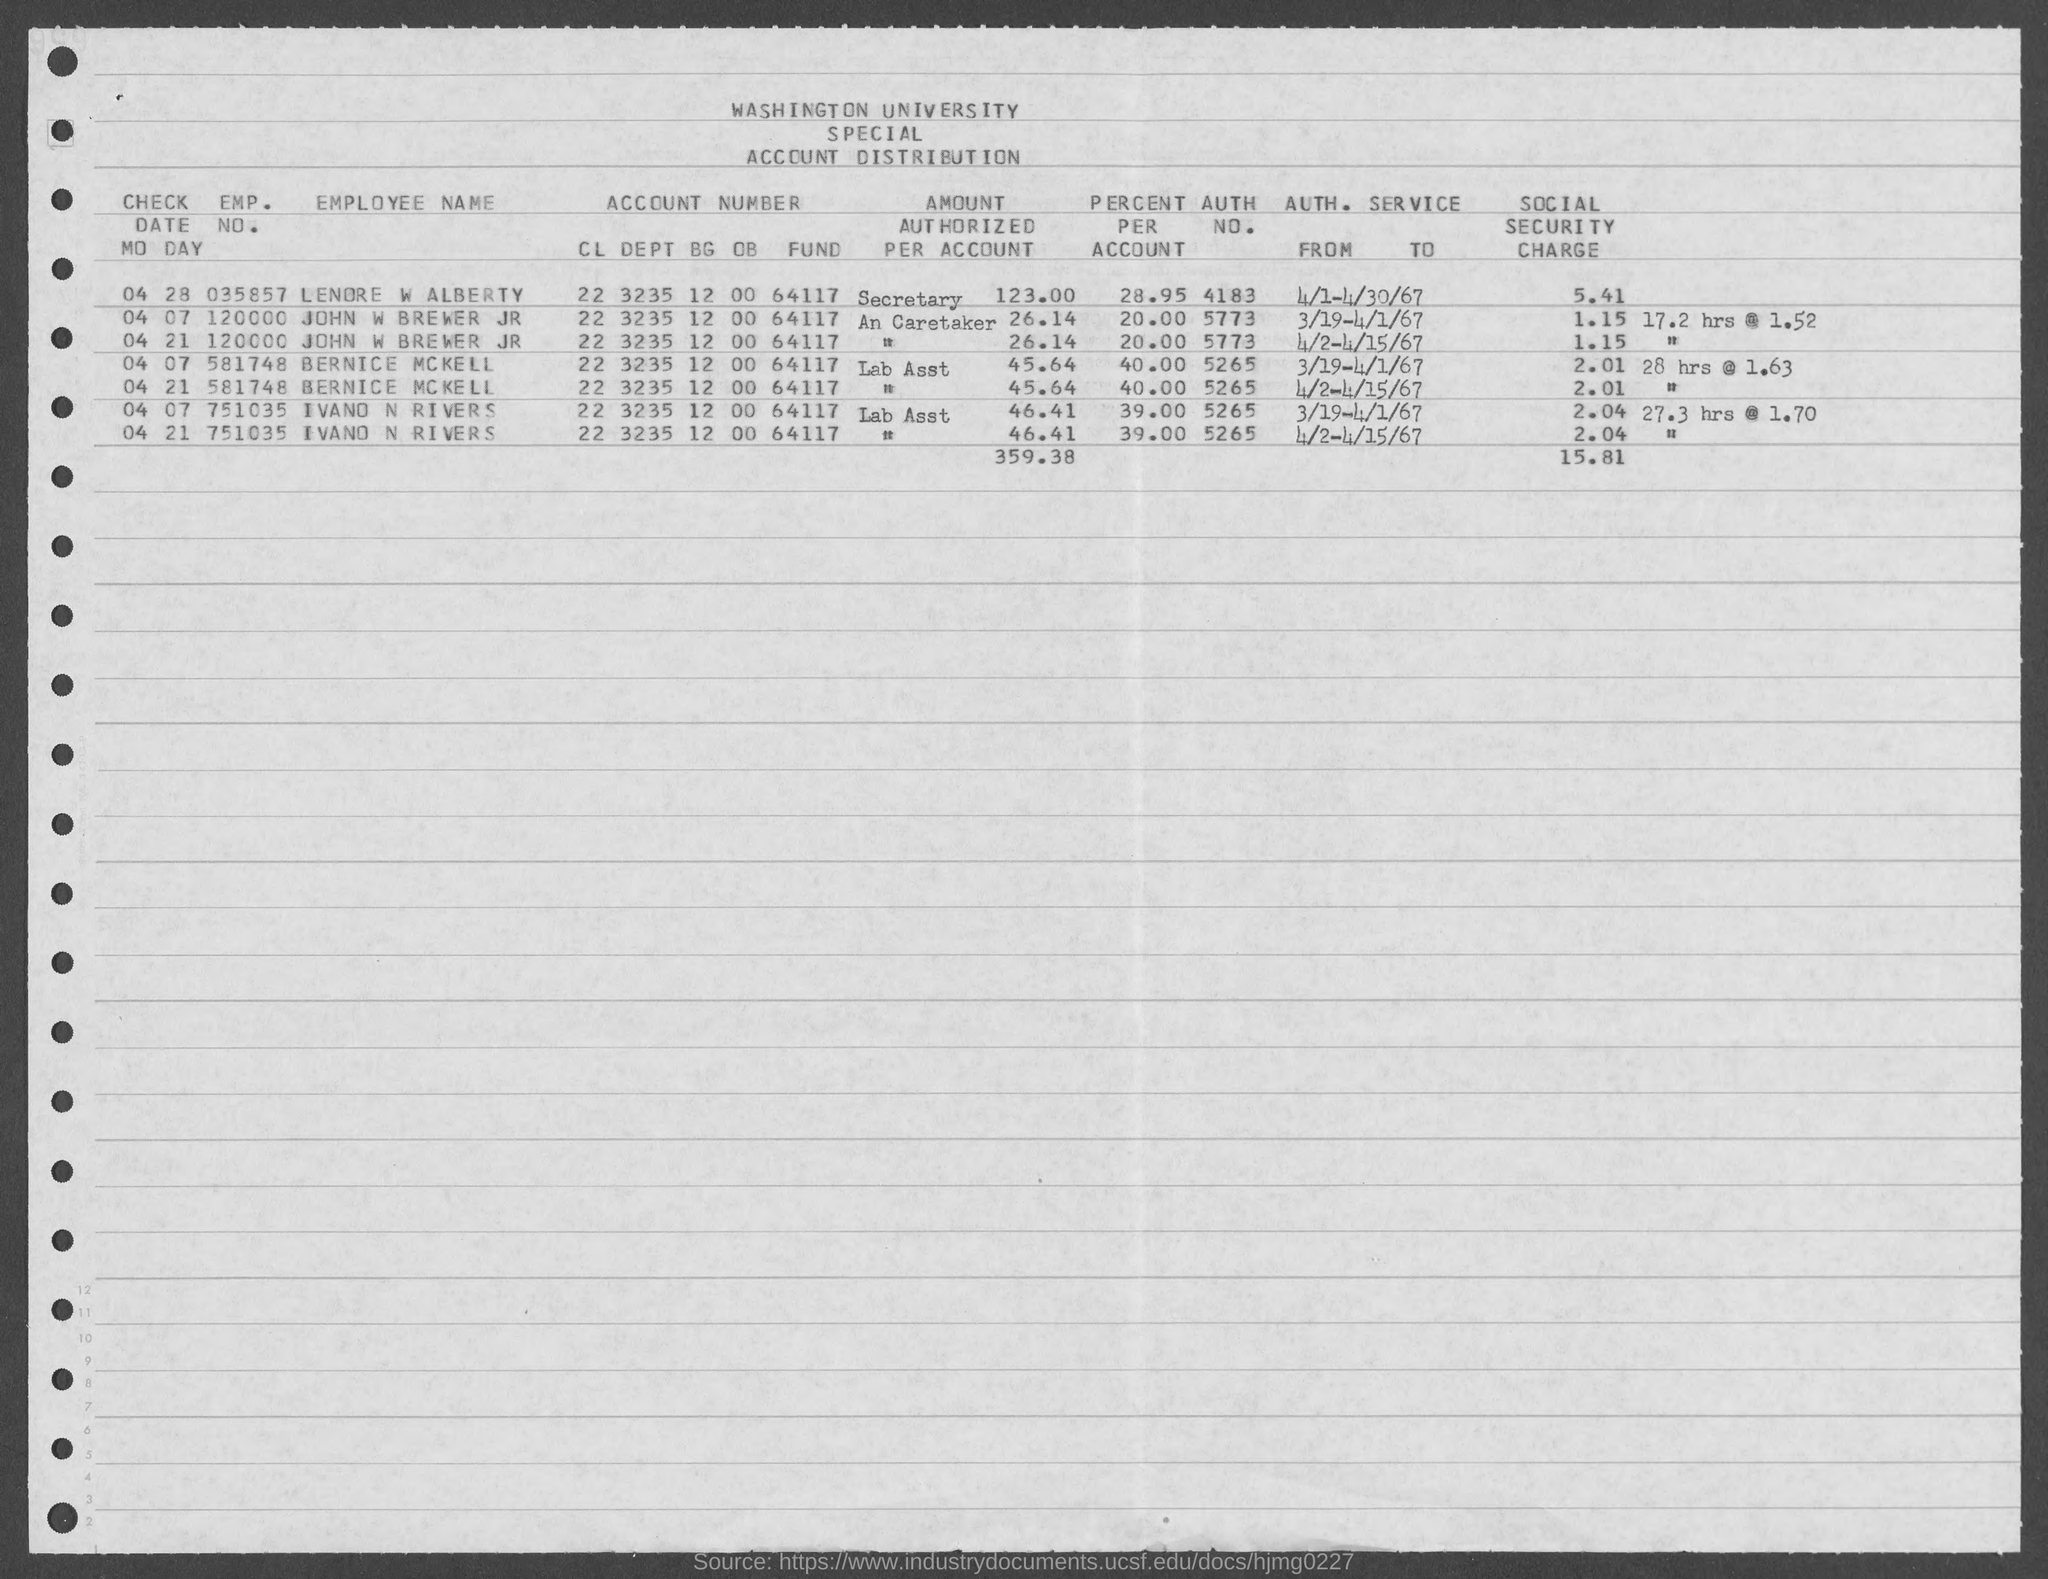Highlight a few significant elements in this photo. The emp. no. of Ivano N Rivers is 751035. The Employer Identification Number (EIN) of Lenore W Alberty is 035857.. John Brewer Jr.'s account percentage is 20.00%. Lenore W Alberty's percent per account is 28.95%. The authorization number of John W. Brewer Jr. is 5773. 